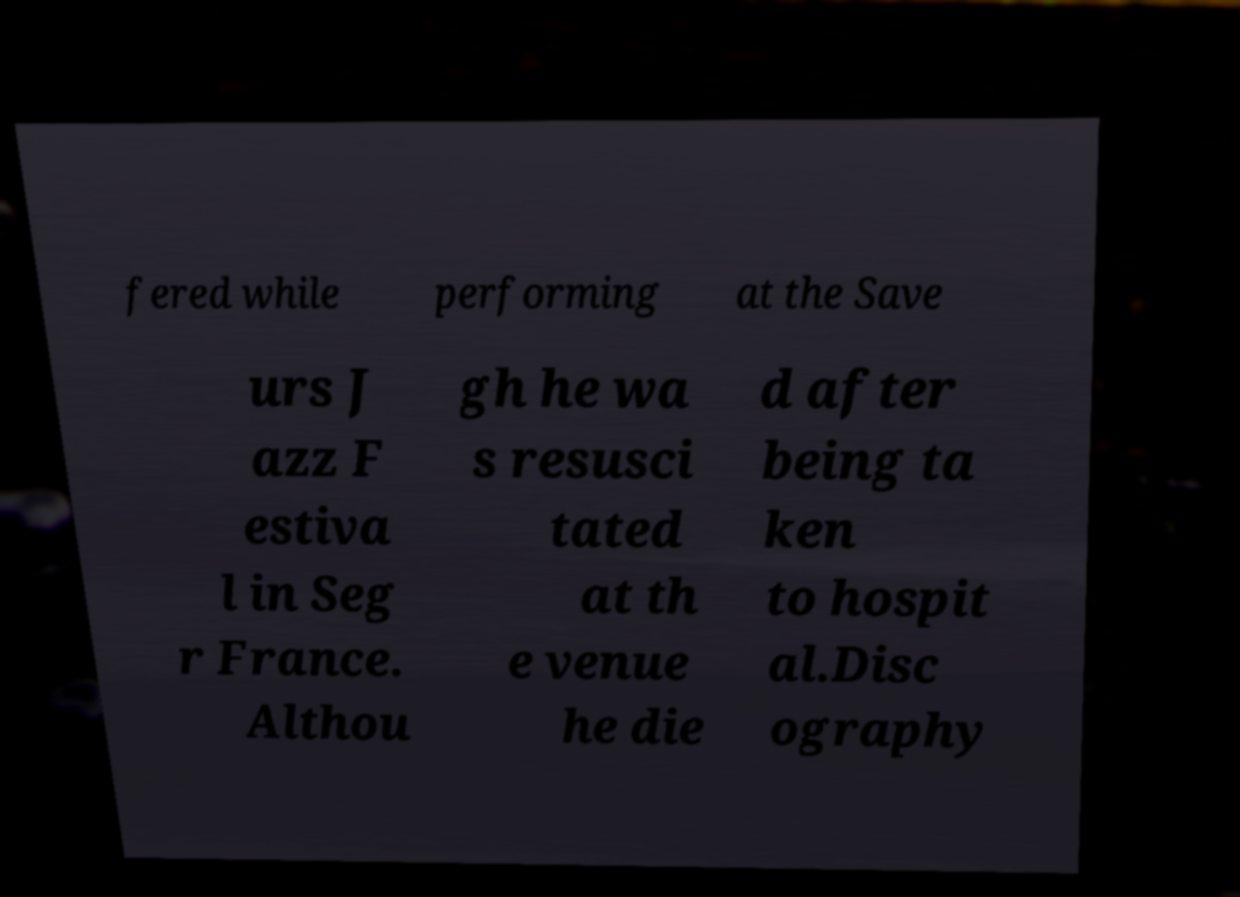Could you assist in decoding the text presented in this image and type it out clearly? fered while performing at the Save urs J azz F estiva l in Seg r France. Althou gh he wa s resusci tated at th e venue he die d after being ta ken to hospit al.Disc ography 